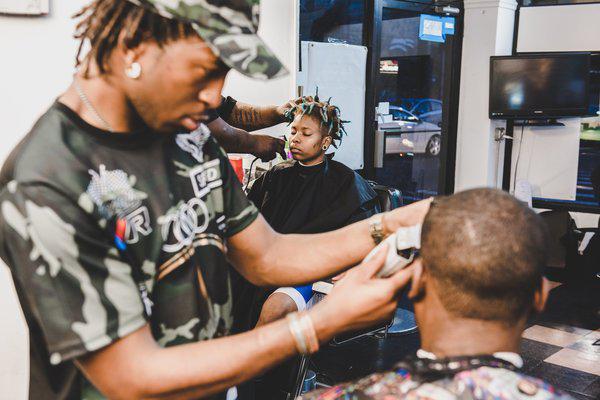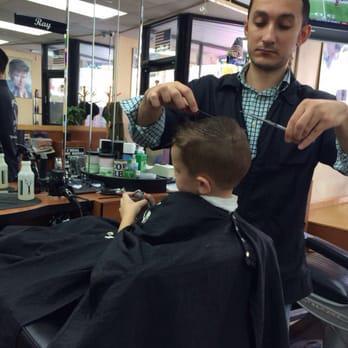The first image is the image on the left, the second image is the image on the right. Analyze the images presented: Is the assertion "There are more people in the barber shop in the right image." valid? Answer yes or no. No. The first image is the image on the left, the second image is the image on the right. Assess this claim about the two images: "The right image has only one person giving a haircut, and one person cutting hair.". Correct or not? Answer yes or no. Yes. 